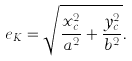Convert formula to latex. <formula><loc_0><loc_0><loc_500><loc_500>e _ { K } = \sqrt { \frac { x _ { c } ^ { 2 } } { a ^ { 2 } } + \frac { y _ { c } ^ { 2 } } { b ^ { 2 } } } .</formula> 